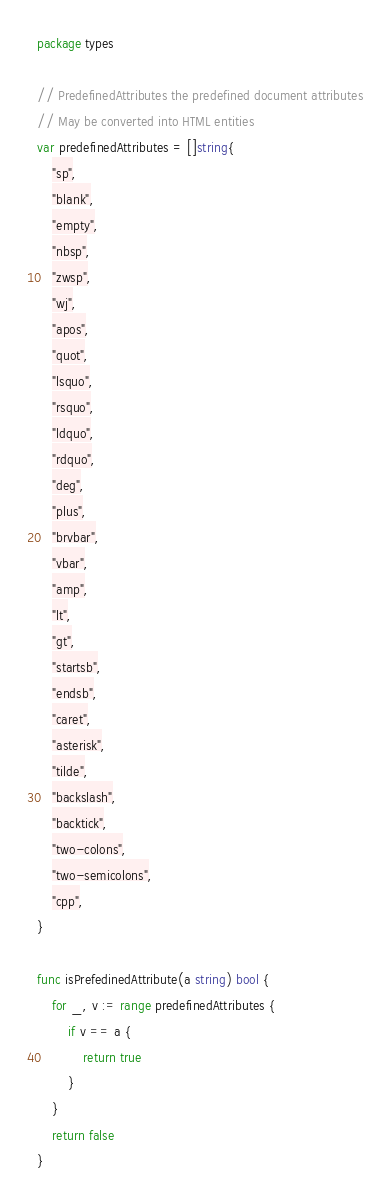Convert code to text. <code><loc_0><loc_0><loc_500><loc_500><_Go_>package types

// PredefinedAttributes the predefined document attributes
// May be converted into HTML entities
var predefinedAttributes = []string{
	"sp",
	"blank",
	"empty",
	"nbsp",
	"zwsp",
	"wj",
	"apos",
	"quot",
	"lsquo",
	"rsquo",
	"ldquo",
	"rdquo",
	"deg",
	"plus",
	"brvbar",
	"vbar",
	"amp",
	"lt",
	"gt",
	"startsb",
	"endsb",
	"caret",
	"asterisk",
	"tilde",
	"backslash",
	"backtick",
	"two-colons",
	"two-semicolons",
	"cpp",
}

func isPrefedinedAttribute(a string) bool {
	for _, v := range predefinedAttributes {
		if v == a {
			return true
		}
	}
	return false
}
</code> 